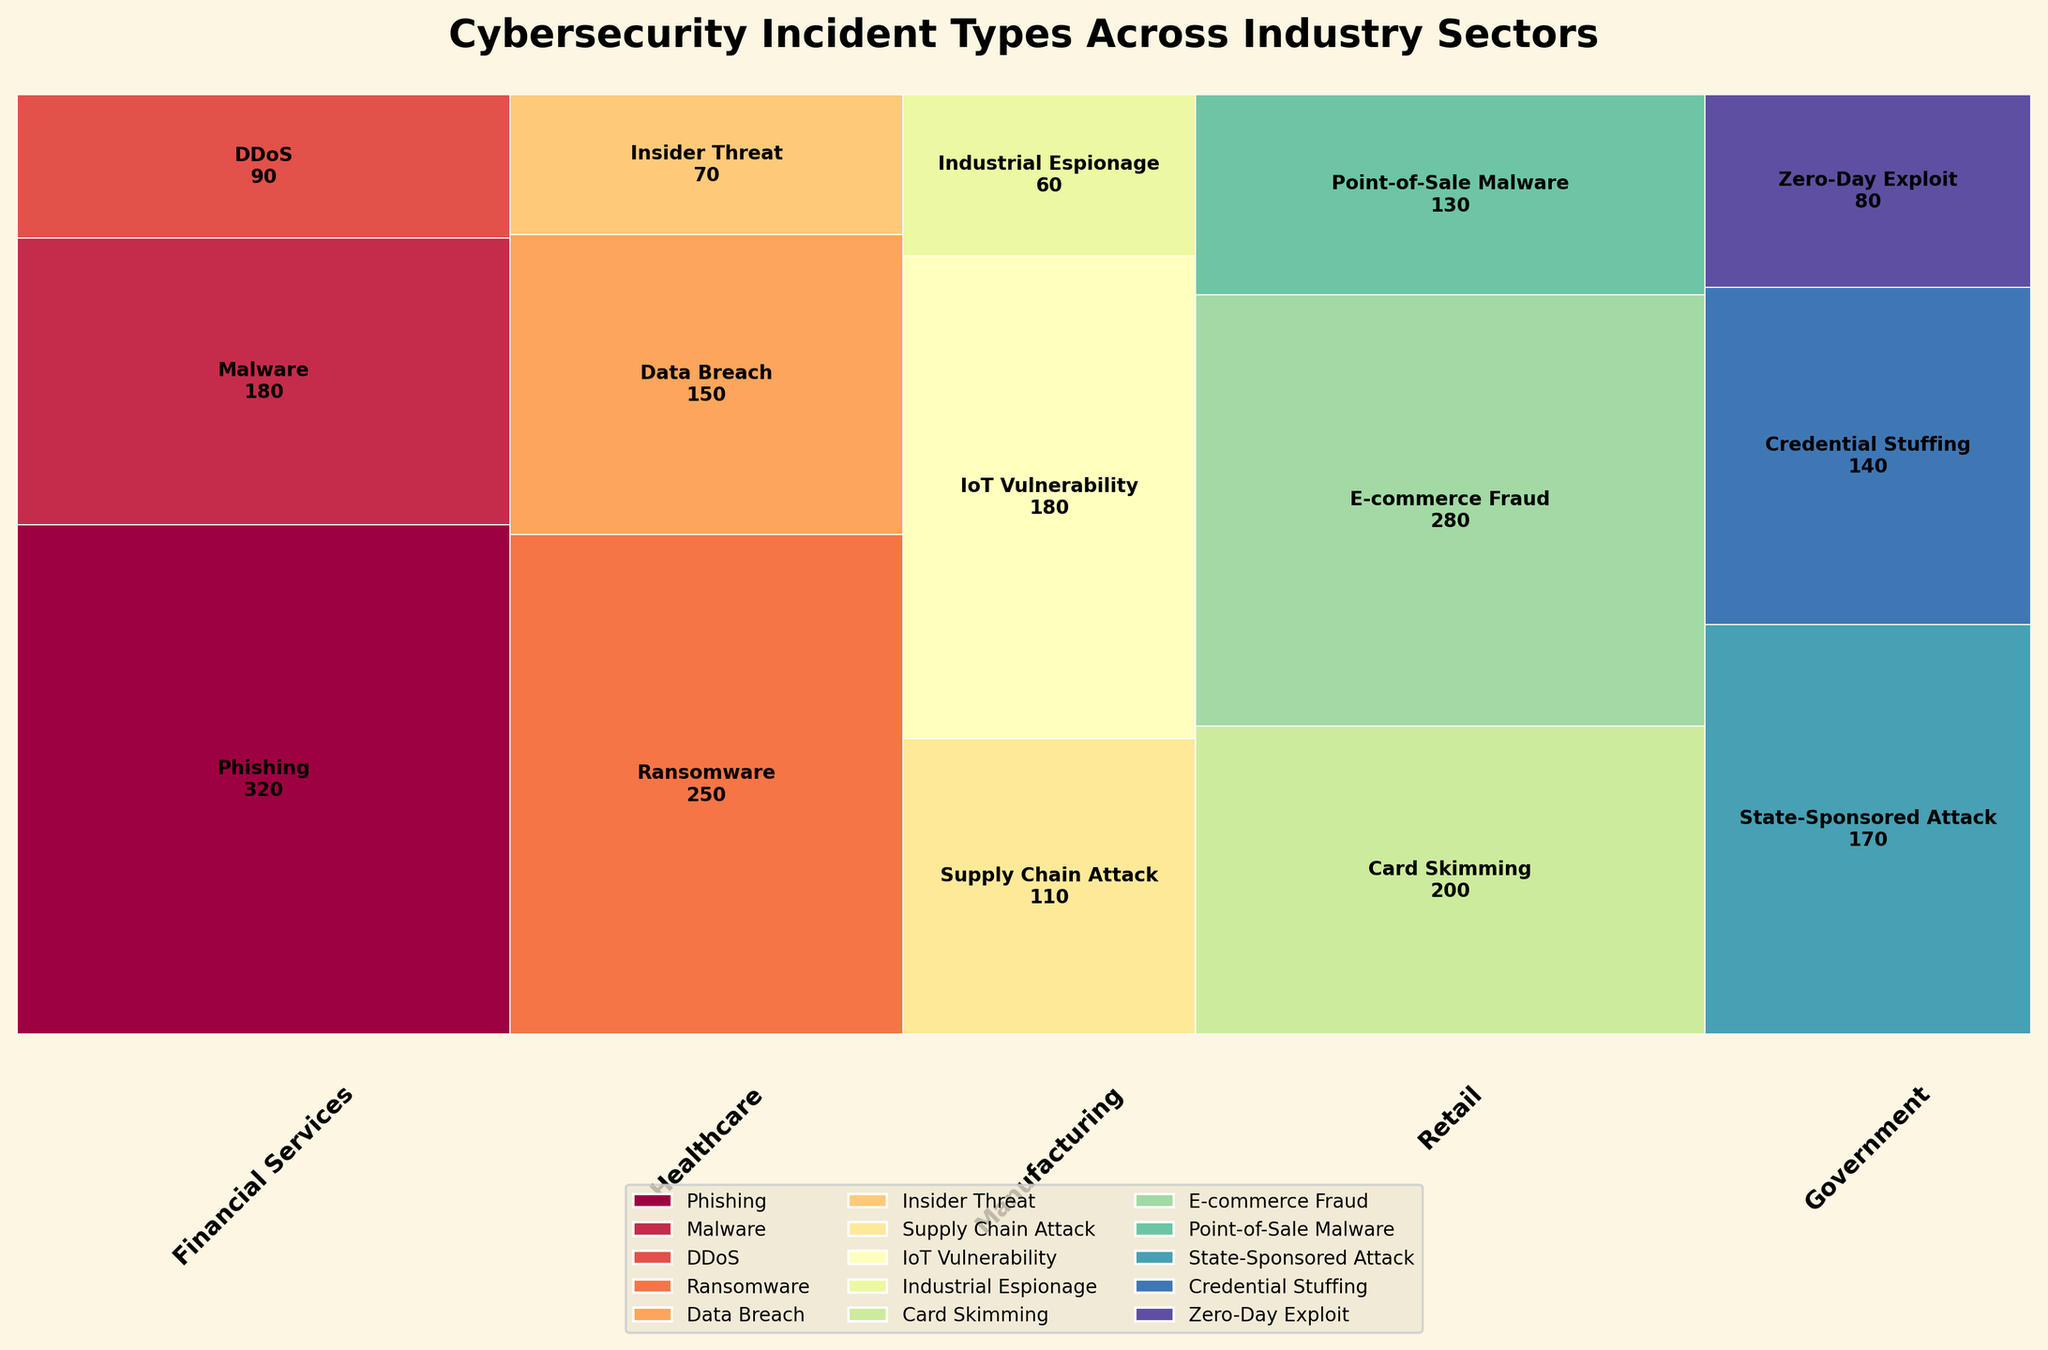What's the title of the plot? The title is usually positioned at the top of the plot and often contains a brief description of the visualized data. In this case, the title's content is very likely found in the data and code provided.
Answer: Cybersecurity Incident Types Across Industry Sectors Which industry sector has the largest proportion of incidents for IoT Vulnerability? Look at the mosaic plot and identify the segment with the label "IoT Vulnerability." Then, check which industry this segment belongs to and compare its size with other industries displaying this incident type.
Answer: Manufacturing How many incident types are represented in the plot? Count the number of distinct colors in the legend, which corresponds to unique incident types. Each color represents a different incident type.
Answer: 15 Which incident type has the highest occurrence in the retail sector? Locate the section labeled "Retail" and identify the incident type that occupies the largest proportion of the sector's total height.
Answer: E-commerce Fraud What is the combined count for Data Breach and Insider Threat in the Healthcare industry? Sum the count for "Data Breach" and "Insider Threat" both under the Healthcare sector from the given data: 150 (Data Breach) + 70 (Insider Threat).
Answer: 220 Which industry sector has the least total incident count? Look at the widths of the segments in the horizontal axis; the smallest width corresponds to the sector with the least total incidents.
Answer: Manufacturing Is the proportion of DDoS incidents higher in Financial Services or Healthcare? Compare the segment heights labeled "DDoS" in both Financial Services and Healthcare sectors. Check which segment proportionally takes more space within its respective sector.
Answer: Financial Services How does the proportion of Ransomware in Healthcare compare to Phishing in Financial Services? Compare the height proportions of the "Ransomware" segment in Healthcare with the "Phishing" segment in Financial Services. Note which segment is larger.
Answer: Ransomware in Healthcare is larger Which incident type is unique to the Government sector? Identify the incident type that appears only within the Government sector and not in any other industry sector from the mosaic plot.
Answer: State-Sponsored Attack What is the percentage of Point-of-Sale Malware incidents within the Retail sector? Calculate the proportion of the "Point-of-Sale Malware" segment in the Retail sector. Point-of-Sale Malware = 130. Sum of all incidents in Retail = 200 + 280 + 130. Percentage = (130 / 610) * 100.
Answer: Approximately 21.3% 